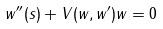Convert formula to latex. <formula><loc_0><loc_0><loc_500><loc_500>w ^ { \prime \prime } ( s ) + V ( w , w ^ { \prime } ) w = 0</formula> 